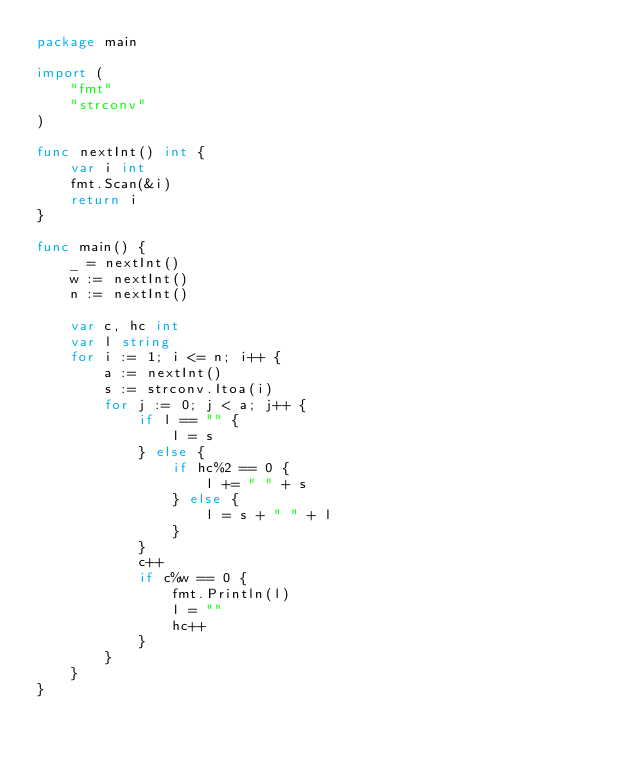<code> <loc_0><loc_0><loc_500><loc_500><_Go_>package main

import (
	"fmt"
	"strconv"
)

func nextInt() int {
	var i int
	fmt.Scan(&i)
	return i
}

func main() {
	_ = nextInt()
	w := nextInt()
	n := nextInt()

	var c, hc int
	var l string
	for i := 1; i <= n; i++ {
		a := nextInt()
		s := strconv.Itoa(i)
		for j := 0; j < a; j++ {
			if l == "" {
				l = s
			} else {
				if hc%2 == 0 {
					l += " " + s
				} else {
					l = s + " " + l
				}
			}
			c++
			if c%w == 0 {
				fmt.Println(l)
				l = ""
				hc++
			}
		}
	}
}</code> 